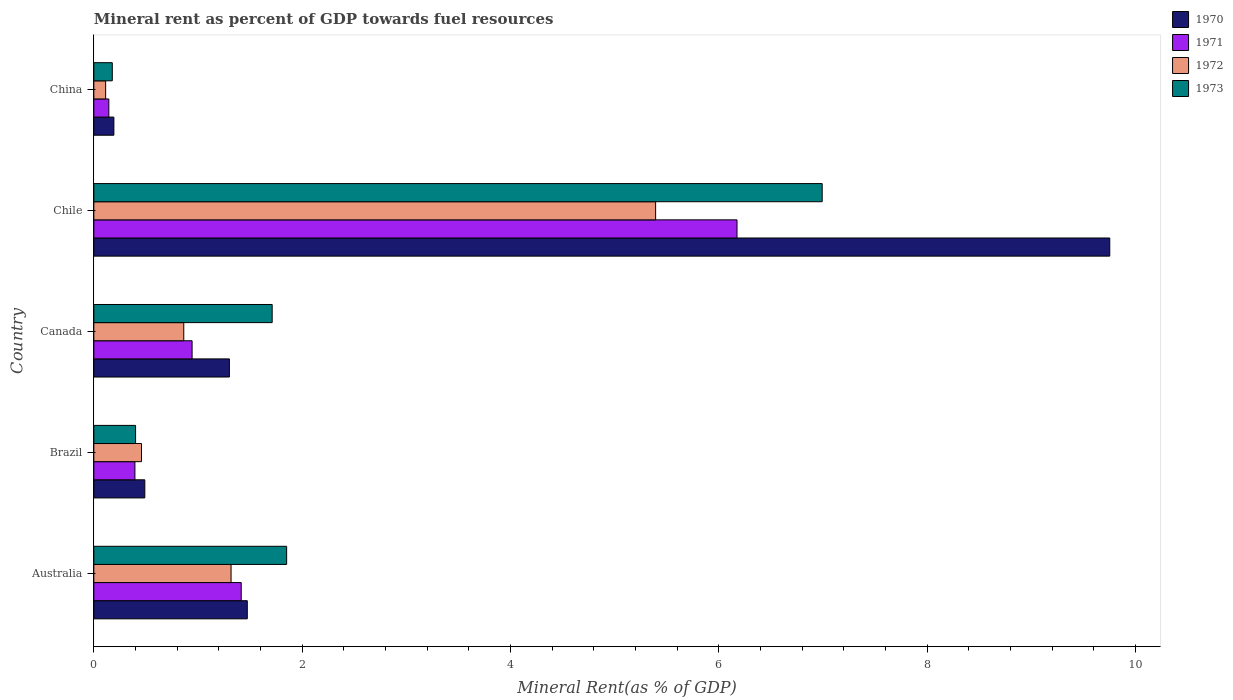How many groups of bars are there?
Your answer should be compact. 5. Are the number of bars per tick equal to the number of legend labels?
Offer a very short reply. Yes. Are the number of bars on each tick of the Y-axis equal?
Your answer should be compact. Yes. How many bars are there on the 2nd tick from the top?
Your answer should be compact. 4. How many bars are there on the 2nd tick from the bottom?
Your answer should be very brief. 4. What is the mineral rent in 1972 in China?
Keep it short and to the point. 0.11. Across all countries, what is the maximum mineral rent in 1973?
Make the answer very short. 6.99. Across all countries, what is the minimum mineral rent in 1971?
Keep it short and to the point. 0.14. What is the total mineral rent in 1971 in the graph?
Make the answer very short. 9.07. What is the difference between the mineral rent in 1971 in Australia and that in Brazil?
Your response must be concise. 1.02. What is the difference between the mineral rent in 1972 in Brazil and the mineral rent in 1971 in Canada?
Your answer should be very brief. -0.49. What is the average mineral rent in 1970 per country?
Give a very brief answer. 2.64. What is the difference between the mineral rent in 1971 and mineral rent in 1970 in Australia?
Offer a terse response. -0.06. In how many countries, is the mineral rent in 1970 greater than 0.4 %?
Offer a very short reply. 4. What is the ratio of the mineral rent in 1971 in Australia to that in China?
Make the answer very short. 9.81. Is the mineral rent in 1973 in Brazil less than that in Chile?
Your answer should be very brief. Yes. Is the difference between the mineral rent in 1971 in Chile and China greater than the difference between the mineral rent in 1970 in Chile and China?
Ensure brevity in your answer.  No. What is the difference between the highest and the second highest mineral rent in 1973?
Your response must be concise. 5.14. What is the difference between the highest and the lowest mineral rent in 1970?
Provide a succinct answer. 9.56. Is the sum of the mineral rent in 1970 in Australia and China greater than the maximum mineral rent in 1973 across all countries?
Provide a succinct answer. No. How many bars are there?
Your response must be concise. 20. Are all the bars in the graph horizontal?
Your answer should be compact. Yes. How many countries are there in the graph?
Your response must be concise. 5. What is the difference between two consecutive major ticks on the X-axis?
Your response must be concise. 2. Are the values on the major ticks of X-axis written in scientific E-notation?
Keep it short and to the point. No. Where does the legend appear in the graph?
Offer a very short reply. Top right. How many legend labels are there?
Your answer should be very brief. 4. How are the legend labels stacked?
Your answer should be very brief. Vertical. What is the title of the graph?
Give a very brief answer. Mineral rent as percent of GDP towards fuel resources. Does "1997" appear as one of the legend labels in the graph?
Give a very brief answer. No. What is the label or title of the X-axis?
Provide a succinct answer. Mineral Rent(as % of GDP). What is the label or title of the Y-axis?
Ensure brevity in your answer.  Country. What is the Mineral Rent(as % of GDP) in 1970 in Australia?
Give a very brief answer. 1.47. What is the Mineral Rent(as % of GDP) in 1971 in Australia?
Offer a terse response. 1.42. What is the Mineral Rent(as % of GDP) of 1972 in Australia?
Offer a very short reply. 1.32. What is the Mineral Rent(as % of GDP) in 1973 in Australia?
Provide a short and direct response. 1.85. What is the Mineral Rent(as % of GDP) in 1970 in Brazil?
Your response must be concise. 0.49. What is the Mineral Rent(as % of GDP) of 1971 in Brazil?
Offer a very short reply. 0.39. What is the Mineral Rent(as % of GDP) of 1972 in Brazil?
Provide a succinct answer. 0.46. What is the Mineral Rent(as % of GDP) of 1973 in Brazil?
Your answer should be very brief. 0.4. What is the Mineral Rent(as % of GDP) of 1970 in Canada?
Your answer should be very brief. 1.3. What is the Mineral Rent(as % of GDP) in 1971 in Canada?
Make the answer very short. 0.94. What is the Mineral Rent(as % of GDP) of 1972 in Canada?
Make the answer very short. 0.86. What is the Mineral Rent(as % of GDP) of 1973 in Canada?
Keep it short and to the point. 1.71. What is the Mineral Rent(as % of GDP) in 1970 in Chile?
Your answer should be compact. 9.75. What is the Mineral Rent(as % of GDP) of 1971 in Chile?
Your answer should be compact. 6.18. What is the Mineral Rent(as % of GDP) in 1972 in Chile?
Keep it short and to the point. 5.39. What is the Mineral Rent(as % of GDP) of 1973 in Chile?
Make the answer very short. 6.99. What is the Mineral Rent(as % of GDP) in 1970 in China?
Keep it short and to the point. 0.19. What is the Mineral Rent(as % of GDP) in 1971 in China?
Your answer should be compact. 0.14. What is the Mineral Rent(as % of GDP) in 1972 in China?
Your response must be concise. 0.11. What is the Mineral Rent(as % of GDP) in 1973 in China?
Your answer should be compact. 0.18. Across all countries, what is the maximum Mineral Rent(as % of GDP) of 1970?
Make the answer very short. 9.75. Across all countries, what is the maximum Mineral Rent(as % of GDP) of 1971?
Offer a terse response. 6.18. Across all countries, what is the maximum Mineral Rent(as % of GDP) of 1972?
Provide a short and direct response. 5.39. Across all countries, what is the maximum Mineral Rent(as % of GDP) in 1973?
Ensure brevity in your answer.  6.99. Across all countries, what is the minimum Mineral Rent(as % of GDP) of 1970?
Make the answer very short. 0.19. Across all countries, what is the minimum Mineral Rent(as % of GDP) in 1971?
Ensure brevity in your answer.  0.14. Across all countries, what is the minimum Mineral Rent(as % of GDP) in 1972?
Your answer should be very brief. 0.11. Across all countries, what is the minimum Mineral Rent(as % of GDP) in 1973?
Offer a very short reply. 0.18. What is the total Mineral Rent(as % of GDP) in 1970 in the graph?
Your answer should be compact. 13.21. What is the total Mineral Rent(as % of GDP) in 1971 in the graph?
Provide a succinct answer. 9.07. What is the total Mineral Rent(as % of GDP) in 1972 in the graph?
Make the answer very short. 8.15. What is the total Mineral Rent(as % of GDP) of 1973 in the graph?
Your response must be concise. 11.14. What is the difference between the Mineral Rent(as % of GDP) in 1970 in Australia and that in Brazil?
Ensure brevity in your answer.  0.98. What is the difference between the Mineral Rent(as % of GDP) of 1971 in Australia and that in Brazil?
Your answer should be very brief. 1.02. What is the difference between the Mineral Rent(as % of GDP) of 1972 in Australia and that in Brazil?
Keep it short and to the point. 0.86. What is the difference between the Mineral Rent(as % of GDP) in 1973 in Australia and that in Brazil?
Ensure brevity in your answer.  1.45. What is the difference between the Mineral Rent(as % of GDP) of 1970 in Australia and that in Canada?
Offer a very short reply. 0.17. What is the difference between the Mineral Rent(as % of GDP) of 1971 in Australia and that in Canada?
Provide a succinct answer. 0.47. What is the difference between the Mineral Rent(as % of GDP) in 1972 in Australia and that in Canada?
Provide a succinct answer. 0.45. What is the difference between the Mineral Rent(as % of GDP) of 1973 in Australia and that in Canada?
Ensure brevity in your answer.  0.14. What is the difference between the Mineral Rent(as % of GDP) in 1970 in Australia and that in Chile?
Your answer should be very brief. -8.28. What is the difference between the Mineral Rent(as % of GDP) in 1971 in Australia and that in Chile?
Make the answer very short. -4.76. What is the difference between the Mineral Rent(as % of GDP) in 1972 in Australia and that in Chile?
Offer a very short reply. -4.08. What is the difference between the Mineral Rent(as % of GDP) of 1973 in Australia and that in Chile?
Give a very brief answer. -5.14. What is the difference between the Mineral Rent(as % of GDP) of 1970 in Australia and that in China?
Your answer should be compact. 1.28. What is the difference between the Mineral Rent(as % of GDP) of 1971 in Australia and that in China?
Offer a very short reply. 1.27. What is the difference between the Mineral Rent(as % of GDP) in 1972 in Australia and that in China?
Your response must be concise. 1.2. What is the difference between the Mineral Rent(as % of GDP) in 1973 in Australia and that in China?
Provide a succinct answer. 1.67. What is the difference between the Mineral Rent(as % of GDP) of 1970 in Brazil and that in Canada?
Your response must be concise. -0.81. What is the difference between the Mineral Rent(as % of GDP) in 1971 in Brazil and that in Canada?
Your response must be concise. -0.55. What is the difference between the Mineral Rent(as % of GDP) of 1972 in Brazil and that in Canada?
Offer a very short reply. -0.41. What is the difference between the Mineral Rent(as % of GDP) of 1973 in Brazil and that in Canada?
Offer a terse response. -1.31. What is the difference between the Mineral Rent(as % of GDP) of 1970 in Brazil and that in Chile?
Give a very brief answer. -9.26. What is the difference between the Mineral Rent(as % of GDP) of 1971 in Brazil and that in Chile?
Give a very brief answer. -5.78. What is the difference between the Mineral Rent(as % of GDP) of 1972 in Brazil and that in Chile?
Provide a short and direct response. -4.94. What is the difference between the Mineral Rent(as % of GDP) of 1973 in Brazil and that in Chile?
Offer a very short reply. -6.59. What is the difference between the Mineral Rent(as % of GDP) in 1970 in Brazil and that in China?
Your answer should be very brief. 0.3. What is the difference between the Mineral Rent(as % of GDP) of 1971 in Brazil and that in China?
Provide a short and direct response. 0.25. What is the difference between the Mineral Rent(as % of GDP) in 1972 in Brazil and that in China?
Offer a very short reply. 0.34. What is the difference between the Mineral Rent(as % of GDP) in 1973 in Brazil and that in China?
Keep it short and to the point. 0.22. What is the difference between the Mineral Rent(as % of GDP) in 1970 in Canada and that in Chile?
Keep it short and to the point. -8.45. What is the difference between the Mineral Rent(as % of GDP) in 1971 in Canada and that in Chile?
Keep it short and to the point. -5.23. What is the difference between the Mineral Rent(as % of GDP) of 1972 in Canada and that in Chile?
Your answer should be very brief. -4.53. What is the difference between the Mineral Rent(as % of GDP) of 1973 in Canada and that in Chile?
Provide a succinct answer. -5.28. What is the difference between the Mineral Rent(as % of GDP) of 1970 in Canada and that in China?
Keep it short and to the point. 1.11. What is the difference between the Mineral Rent(as % of GDP) in 1971 in Canada and that in China?
Offer a very short reply. 0.8. What is the difference between the Mineral Rent(as % of GDP) of 1972 in Canada and that in China?
Offer a very short reply. 0.75. What is the difference between the Mineral Rent(as % of GDP) in 1973 in Canada and that in China?
Offer a terse response. 1.53. What is the difference between the Mineral Rent(as % of GDP) of 1970 in Chile and that in China?
Your answer should be very brief. 9.56. What is the difference between the Mineral Rent(as % of GDP) of 1971 in Chile and that in China?
Make the answer very short. 6.03. What is the difference between the Mineral Rent(as % of GDP) in 1972 in Chile and that in China?
Your answer should be very brief. 5.28. What is the difference between the Mineral Rent(as % of GDP) in 1973 in Chile and that in China?
Your answer should be very brief. 6.82. What is the difference between the Mineral Rent(as % of GDP) in 1970 in Australia and the Mineral Rent(as % of GDP) in 1971 in Brazil?
Offer a very short reply. 1.08. What is the difference between the Mineral Rent(as % of GDP) of 1970 in Australia and the Mineral Rent(as % of GDP) of 1972 in Brazil?
Ensure brevity in your answer.  1.02. What is the difference between the Mineral Rent(as % of GDP) of 1970 in Australia and the Mineral Rent(as % of GDP) of 1973 in Brazil?
Provide a short and direct response. 1.07. What is the difference between the Mineral Rent(as % of GDP) in 1971 in Australia and the Mineral Rent(as % of GDP) in 1972 in Brazil?
Give a very brief answer. 0.96. What is the difference between the Mineral Rent(as % of GDP) in 1971 in Australia and the Mineral Rent(as % of GDP) in 1973 in Brazil?
Offer a terse response. 1.01. What is the difference between the Mineral Rent(as % of GDP) of 1972 in Australia and the Mineral Rent(as % of GDP) of 1973 in Brazil?
Offer a very short reply. 0.92. What is the difference between the Mineral Rent(as % of GDP) of 1970 in Australia and the Mineral Rent(as % of GDP) of 1971 in Canada?
Offer a very short reply. 0.53. What is the difference between the Mineral Rent(as % of GDP) in 1970 in Australia and the Mineral Rent(as % of GDP) in 1972 in Canada?
Offer a terse response. 0.61. What is the difference between the Mineral Rent(as % of GDP) in 1970 in Australia and the Mineral Rent(as % of GDP) in 1973 in Canada?
Give a very brief answer. -0.24. What is the difference between the Mineral Rent(as % of GDP) of 1971 in Australia and the Mineral Rent(as % of GDP) of 1972 in Canada?
Keep it short and to the point. 0.55. What is the difference between the Mineral Rent(as % of GDP) of 1971 in Australia and the Mineral Rent(as % of GDP) of 1973 in Canada?
Ensure brevity in your answer.  -0.3. What is the difference between the Mineral Rent(as % of GDP) in 1972 in Australia and the Mineral Rent(as % of GDP) in 1973 in Canada?
Your response must be concise. -0.39. What is the difference between the Mineral Rent(as % of GDP) in 1970 in Australia and the Mineral Rent(as % of GDP) in 1971 in Chile?
Offer a terse response. -4.7. What is the difference between the Mineral Rent(as % of GDP) in 1970 in Australia and the Mineral Rent(as % of GDP) in 1972 in Chile?
Keep it short and to the point. -3.92. What is the difference between the Mineral Rent(as % of GDP) in 1970 in Australia and the Mineral Rent(as % of GDP) in 1973 in Chile?
Offer a terse response. -5.52. What is the difference between the Mineral Rent(as % of GDP) of 1971 in Australia and the Mineral Rent(as % of GDP) of 1972 in Chile?
Provide a short and direct response. -3.98. What is the difference between the Mineral Rent(as % of GDP) in 1971 in Australia and the Mineral Rent(as % of GDP) in 1973 in Chile?
Your answer should be compact. -5.58. What is the difference between the Mineral Rent(as % of GDP) in 1972 in Australia and the Mineral Rent(as % of GDP) in 1973 in Chile?
Give a very brief answer. -5.68. What is the difference between the Mineral Rent(as % of GDP) in 1970 in Australia and the Mineral Rent(as % of GDP) in 1971 in China?
Your response must be concise. 1.33. What is the difference between the Mineral Rent(as % of GDP) in 1970 in Australia and the Mineral Rent(as % of GDP) in 1972 in China?
Ensure brevity in your answer.  1.36. What is the difference between the Mineral Rent(as % of GDP) of 1970 in Australia and the Mineral Rent(as % of GDP) of 1973 in China?
Your answer should be compact. 1.3. What is the difference between the Mineral Rent(as % of GDP) of 1971 in Australia and the Mineral Rent(as % of GDP) of 1972 in China?
Your answer should be very brief. 1.3. What is the difference between the Mineral Rent(as % of GDP) of 1971 in Australia and the Mineral Rent(as % of GDP) of 1973 in China?
Your response must be concise. 1.24. What is the difference between the Mineral Rent(as % of GDP) in 1972 in Australia and the Mineral Rent(as % of GDP) in 1973 in China?
Your answer should be very brief. 1.14. What is the difference between the Mineral Rent(as % of GDP) of 1970 in Brazil and the Mineral Rent(as % of GDP) of 1971 in Canada?
Offer a terse response. -0.45. What is the difference between the Mineral Rent(as % of GDP) of 1970 in Brazil and the Mineral Rent(as % of GDP) of 1972 in Canada?
Keep it short and to the point. -0.37. What is the difference between the Mineral Rent(as % of GDP) in 1970 in Brazil and the Mineral Rent(as % of GDP) in 1973 in Canada?
Your answer should be compact. -1.22. What is the difference between the Mineral Rent(as % of GDP) in 1971 in Brazil and the Mineral Rent(as % of GDP) in 1972 in Canada?
Your answer should be very brief. -0.47. What is the difference between the Mineral Rent(as % of GDP) in 1971 in Brazil and the Mineral Rent(as % of GDP) in 1973 in Canada?
Give a very brief answer. -1.32. What is the difference between the Mineral Rent(as % of GDP) in 1972 in Brazil and the Mineral Rent(as % of GDP) in 1973 in Canada?
Keep it short and to the point. -1.25. What is the difference between the Mineral Rent(as % of GDP) of 1970 in Brazil and the Mineral Rent(as % of GDP) of 1971 in Chile?
Your answer should be very brief. -5.69. What is the difference between the Mineral Rent(as % of GDP) of 1970 in Brazil and the Mineral Rent(as % of GDP) of 1972 in Chile?
Your response must be concise. -4.9. What is the difference between the Mineral Rent(as % of GDP) of 1970 in Brazil and the Mineral Rent(as % of GDP) of 1973 in Chile?
Keep it short and to the point. -6.5. What is the difference between the Mineral Rent(as % of GDP) in 1971 in Brazil and the Mineral Rent(as % of GDP) in 1972 in Chile?
Keep it short and to the point. -5. What is the difference between the Mineral Rent(as % of GDP) in 1971 in Brazil and the Mineral Rent(as % of GDP) in 1973 in Chile?
Offer a terse response. -6.6. What is the difference between the Mineral Rent(as % of GDP) of 1972 in Brazil and the Mineral Rent(as % of GDP) of 1973 in Chile?
Your answer should be compact. -6.54. What is the difference between the Mineral Rent(as % of GDP) in 1970 in Brazil and the Mineral Rent(as % of GDP) in 1971 in China?
Ensure brevity in your answer.  0.35. What is the difference between the Mineral Rent(as % of GDP) of 1970 in Brazil and the Mineral Rent(as % of GDP) of 1972 in China?
Offer a terse response. 0.38. What is the difference between the Mineral Rent(as % of GDP) of 1970 in Brazil and the Mineral Rent(as % of GDP) of 1973 in China?
Ensure brevity in your answer.  0.31. What is the difference between the Mineral Rent(as % of GDP) of 1971 in Brazil and the Mineral Rent(as % of GDP) of 1972 in China?
Give a very brief answer. 0.28. What is the difference between the Mineral Rent(as % of GDP) of 1971 in Brazil and the Mineral Rent(as % of GDP) of 1973 in China?
Keep it short and to the point. 0.22. What is the difference between the Mineral Rent(as % of GDP) of 1972 in Brazil and the Mineral Rent(as % of GDP) of 1973 in China?
Ensure brevity in your answer.  0.28. What is the difference between the Mineral Rent(as % of GDP) in 1970 in Canada and the Mineral Rent(as % of GDP) in 1971 in Chile?
Your answer should be very brief. -4.87. What is the difference between the Mineral Rent(as % of GDP) of 1970 in Canada and the Mineral Rent(as % of GDP) of 1972 in Chile?
Offer a very short reply. -4.09. What is the difference between the Mineral Rent(as % of GDP) in 1970 in Canada and the Mineral Rent(as % of GDP) in 1973 in Chile?
Give a very brief answer. -5.69. What is the difference between the Mineral Rent(as % of GDP) in 1971 in Canada and the Mineral Rent(as % of GDP) in 1972 in Chile?
Keep it short and to the point. -4.45. What is the difference between the Mineral Rent(as % of GDP) of 1971 in Canada and the Mineral Rent(as % of GDP) of 1973 in Chile?
Your response must be concise. -6.05. What is the difference between the Mineral Rent(as % of GDP) in 1972 in Canada and the Mineral Rent(as % of GDP) in 1973 in Chile?
Your answer should be very brief. -6.13. What is the difference between the Mineral Rent(as % of GDP) in 1970 in Canada and the Mineral Rent(as % of GDP) in 1971 in China?
Keep it short and to the point. 1.16. What is the difference between the Mineral Rent(as % of GDP) of 1970 in Canada and the Mineral Rent(as % of GDP) of 1972 in China?
Your answer should be compact. 1.19. What is the difference between the Mineral Rent(as % of GDP) of 1970 in Canada and the Mineral Rent(as % of GDP) of 1973 in China?
Make the answer very short. 1.12. What is the difference between the Mineral Rent(as % of GDP) of 1971 in Canada and the Mineral Rent(as % of GDP) of 1972 in China?
Your response must be concise. 0.83. What is the difference between the Mineral Rent(as % of GDP) of 1971 in Canada and the Mineral Rent(as % of GDP) of 1973 in China?
Offer a very short reply. 0.77. What is the difference between the Mineral Rent(as % of GDP) of 1972 in Canada and the Mineral Rent(as % of GDP) of 1973 in China?
Provide a succinct answer. 0.69. What is the difference between the Mineral Rent(as % of GDP) of 1970 in Chile and the Mineral Rent(as % of GDP) of 1971 in China?
Offer a very short reply. 9.61. What is the difference between the Mineral Rent(as % of GDP) of 1970 in Chile and the Mineral Rent(as % of GDP) of 1972 in China?
Your answer should be very brief. 9.64. What is the difference between the Mineral Rent(as % of GDP) in 1970 in Chile and the Mineral Rent(as % of GDP) in 1973 in China?
Give a very brief answer. 9.58. What is the difference between the Mineral Rent(as % of GDP) of 1971 in Chile and the Mineral Rent(as % of GDP) of 1972 in China?
Make the answer very short. 6.06. What is the difference between the Mineral Rent(as % of GDP) in 1971 in Chile and the Mineral Rent(as % of GDP) in 1973 in China?
Ensure brevity in your answer.  6. What is the difference between the Mineral Rent(as % of GDP) of 1972 in Chile and the Mineral Rent(as % of GDP) of 1973 in China?
Offer a very short reply. 5.22. What is the average Mineral Rent(as % of GDP) in 1970 per country?
Provide a short and direct response. 2.64. What is the average Mineral Rent(as % of GDP) of 1971 per country?
Offer a terse response. 1.81. What is the average Mineral Rent(as % of GDP) in 1972 per country?
Your response must be concise. 1.63. What is the average Mineral Rent(as % of GDP) of 1973 per country?
Ensure brevity in your answer.  2.23. What is the difference between the Mineral Rent(as % of GDP) in 1970 and Mineral Rent(as % of GDP) in 1971 in Australia?
Offer a very short reply. 0.06. What is the difference between the Mineral Rent(as % of GDP) of 1970 and Mineral Rent(as % of GDP) of 1972 in Australia?
Provide a succinct answer. 0.16. What is the difference between the Mineral Rent(as % of GDP) of 1970 and Mineral Rent(as % of GDP) of 1973 in Australia?
Keep it short and to the point. -0.38. What is the difference between the Mineral Rent(as % of GDP) in 1971 and Mineral Rent(as % of GDP) in 1972 in Australia?
Give a very brief answer. 0.1. What is the difference between the Mineral Rent(as % of GDP) in 1971 and Mineral Rent(as % of GDP) in 1973 in Australia?
Provide a succinct answer. -0.44. What is the difference between the Mineral Rent(as % of GDP) in 1972 and Mineral Rent(as % of GDP) in 1973 in Australia?
Offer a very short reply. -0.53. What is the difference between the Mineral Rent(as % of GDP) of 1970 and Mineral Rent(as % of GDP) of 1971 in Brazil?
Provide a succinct answer. 0.1. What is the difference between the Mineral Rent(as % of GDP) in 1970 and Mineral Rent(as % of GDP) in 1972 in Brazil?
Offer a terse response. 0.03. What is the difference between the Mineral Rent(as % of GDP) in 1970 and Mineral Rent(as % of GDP) in 1973 in Brazil?
Keep it short and to the point. 0.09. What is the difference between the Mineral Rent(as % of GDP) of 1971 and Mineral Rent(as % of GDP) of 1972 in Brazil?
Ensure brevity in your answer.  -0.06. What is the difference between the Mineral Rent(as % of GDP) in 1971 and Mineral Rent(as % of GDP) in 1973 in Brazil?
Make the answer very short. -0.01. What is the difference between the Mineral Rent(as % of GDP) of 1972 and Mineral Rent(as % of GDP) of 1973 in Brazil?
Your response must be concise. 0.06. What is the difference between the Mineral Rent(as % of GDP) in 1970 and Mineral Rent(as % of GDP) in 1971 in Canada?
Offer a very short reply. 0.36. What is the difference between the Mineral Rent(as % of GDP) of 1970 and Mineral Rent(as % of GDP) of 1972 in Canada?
Your response must be concise. 0.44. What is the difference between the Mineral Rent(as % of GDP) in 1970 and Mineral Rent(as % of GDP) in 1973 in Canada?
Give a very brief answer. -0.41. What is the difference between the Mineral Rent(as % of GDP) of 1971 and Mineral Rent(as % of GDP) of 1973 in Canada?
Offer a very short reply. -0.77. What is the difference between the Mineral Rent(as % of GDP) of 1972 and Mineral Rent(as % of GDP) of 1973 in Canada?
Provide a short and direct response. -0.85. What is the difference between the Mineral Rent(as % of GDP) in 1970 and Mineral Rent(as % of GDP) in 1971 in Chile?
Keep it short and to the point. 3.58. What is the difference between the Mineral Rent(as % of GDP) of 1970 and Mineral Rent(as % of GDP) of 1972 in Chile?
Offer a very short reply. 4.36. What is the difference between the Mineral Rent(as % of GDP) in 1970 and Mineral Rent(as % of GDP) in 1973 in Chile?
Keep it short and to the point. 2.76. What is the difference between the Mineral Rent(as % of GDP) of 1971 and Mineral Rent(as % of GDP) of 1972 in Chile?
Provide a succinct answer. 0.78. What is the difference between the Mineral Rent(as % of GDP) in 1971 and Mineral Rent(as % of GDP) in 1973 in Chile?
Keep it short and to the point. -0.82. What is the difference between the Mineral Rent(as % of GDP) of 1972 and Mineral Rent(as % of GDP) of 1973 in Chile?
Provide a short and direct response. -1.6. What is the difference between the Mineral Rent(as % of GDP) of 1970 and Mineral Rent(as % of GDP) of 1971 in China?
Your answer should be compact. 0.05. What is the difference between the Mineral Rent(as % of GDP) of 1970 and Mineral Rent(as % of GDP) of 1972 in China?
Your answer should be compact. 0.08. What is the difference between the Mineral Rent(as % of GDP) in 1970 and Mineral Rent(as % of GDP) in 1973 in China?
Your answer should be compact. 0.02. What is the difference between the Mineral Rent(as % of GDP) of 1971 and Mineral Rent(as % of GDP) of 1972 in China?
Make the answer very short. 0.03. What is the difference between the Mineral Rent(as % of GDP) of 1971 and Mineral Rent(as % of GDP) of 1973 in China?
Provide a short and direct response. -0.03. What is the difference between the Mineral Rent(as % of GDP) of 1972 and Mineral Rent(as % of GDP) of 1973 in China?
Your answer should be compact. -0.06. What is the ratio of the Mineral Rent(as % of GDP) in 1970 in Australia to that in Brazil?
Your response must be concise. 3.01. What is the ratio of the Mineral Rent(as % of GDP) in 1971 in Australia to that in Brazil?
Offer a terse response. 3.59. What is the ratio of the Mineral Rent(as % of GDP) of 1972 in Australia to that in Brazil?
Provide a short and direct response. 2.88. What is the ratio of the Mineral Rent(as % of GDP) of 1973 in Australia to that in Brazil?
Offer a terse response. 4.62. What is the ratio of the Mineral Rent(as % of GDP) in 1970 in Australia to that in Canada?
Keep it short and to the point. 1.13. What is the ratio of the Mineral Rent(as % of GDP) of 1971 in Australia to that in Canada?
Your answer should be compact. 1.5. What is the ratio of the Mineral Rent(as % of GDP) in 1972 in Australia to that in Canada?
Give a very brief answer. 1.53. What is the ratio of the Mineral Rent(as % of GDP) in 1973 in Australia to that in Canada?
Keep it short and to the point. 1.08. What is the ratio of the Mineral Rent(as % of GDP) of 1970 in Australia to that in Chile?
Provide a succinct answer. 0.15. What is the ratio of the Mineral Rent(as % of GDP) of 1971 in Australia to that in Chile?
Provide a short and direct response. 0.23. What is the ratio of the Mineral Rent(as % of GDP) in 1972 in Australia to that in Chile?
Ensure brevity in your answer.  0.24. What is the ratio of the Mineral Rent(as % of GDP) of 1973 in Australia to that in Chile?
Your answer should be very brief. 0.26. What is the ratio of the Mineral Rent(as % of GDP) in 1970 in Australia to that in China?
Your answer should be very brief. 7.65. What is the ratio of the Mineral Rent(as % of GDP) of 1971 in Australia to that in China?
Ensure brevity in your answer.  9.81. What is the ratio of the Mineral Rent(as % of GDP) in 1972 in Australia to that in China?
Your answer should be compact. 11.62. What is the ratio of the Mineral Rent(as % of GDP) of 1973 in Australia to that in China?
Your answer should be compact. 10.43. What is the ratio of the Mineral Rent(as % of GDP) of 1970 in Brazil to that in Canada?
Your response must be concise. 0.38. What is the ratio of the Mineral Rent(as % of GDP) in 1971 in Brazil to that in Canada?
Your response must be concise. 0.42. What is the ratio of the Mineral Rent(as % of GDP) in 1972 in Brazil to that in Canada?
Offer a terse response. 0.53. What is the ratio of the Mineral Rent(as % of GDP) of 1973 in Brazil to that in Canada?
Keep it short and to the point. 0.23. What is the ratio of the Mineral Rent(as % of GDP) of 1970 in Brazil to that in Chile?
Your answer should be compact. 0.05. What is the ratio of the Mineral Rent(as % of GDP) in 1971 in Brazil to that in Chile?
Give a very brief answer. 0.06. What is the ratio of the Mineral Rent(as % of GDP) in 1972 in Brazil to that in Chile?
Keep it short and to the point. 0.08. What is the ratio of the Mineral Rent(as % of GDP) of 1973 in Brazil to that in Chile?
Your response must be concise. 0.06. What is the ratio of the Mineral Rent(as % of GDP) of 1970 in Brazil to that in China?
Offer a very short reply. 2.54. What is the ratio of the Mineral Rent(as % of GDP) of 1971 in Brazil to that in China?
Give a very brief answer. 2.74. What is the ratio of the Mineral Rent(as % of GDP) in 1972 in Brazil to that in China?
Offer a terse response. 4.03. What is the ratio of the Mineral Rent(as % of GDP) of 1973 in Brazil to that in China?
Offer a terse response. 2.26. What is the ratio of the Mineral Rent(as % of GDP) in 1970 in Canada to that in Chile?
Your answer should be very brief. 0.13. What is the ratio of the Mineral Rent(as % of GDP) of 1971 in Canada to that in Chile?
Keep it short and to the point. 0.15. What is the ratio of the Mineral Rent(as % of GDP) in 1972 in Canada to that in Chile?
Your answer should be compact. 0.16. What is the ratio of the Mineral Rent(as % of GDP) in 1973 in Canada to that in Chile?
Provide a short and direct response. 0.24. What is the ratio of the Mineral Rent(as % of GDP) in 1970 in Canada to that in China?
Provide a short and direct response. 6.76. What is the ratio of the Mineral Rent(as % of GDP) in 1971 in Canada to that in China?
Your answer should be very brief. 6.54. What is the ratio of the Mineral Rent(as % of GDP) of 1972 in Canada to that in China?
Your response must be concise. 7.61. What is the ratio of the Mineral Rent(as % of GDP) in 1973 in Canada to that in China?
Ensure brevity in your answer.  9.65. What is the ratio of the Mineral Rent(as % of GDP) in 1970 in Chile to that in China?
Make the answer very short. 50.65. What is the ratio of the Mineral Rent(as % of GDP) in 1971 in Chile to that in China?
Provide a short and direct response. 42.82. What is the ratio of the Mineral Rent(as % of GDP) in 1972 in Chile to that in China?
Your answer should be very brief. 47.55. What is the ratio of the Mineral Rent(as % of GDP) of 1973 in Chile to that in China?
Offer a terse response. 39.41. What is the difference between the highest and the second highest Mineral Rent(as % of GDP) of 1970?
Your answer should be compact. 8.28. What is the difference between the highest and the second highest Mineral Rent(as % of GDP) in 1971?
Your response must be concise. 4.76. What is the difference between the highest and the second highest Mineral Rent(as % of GDP) in 1972?
Provide a short and direct response. 4.08. What is the difference between the highest and the second highest Mineral Rent(as % of GDP) of 1973?
Your answer should be very brief. 5.14. What is the difference between the highest and the lowest Mineral Rent(as % of GDP) in 1970?
Your response must be concise. 9.56. What is the difference between the highest and the lowest Mineral Rent(as % of GDP) in 1971?
Your response must be concise. 6.03. What is the difference between the highest and the lowest Mineral Rent(as % of GDP) in 1972?
Your answer should be compact. 5.28. What is the difference between the highest and the lowest Mineral Rent(as % of GDP) in 1973?
Provide a short and direct response. 6.82. 